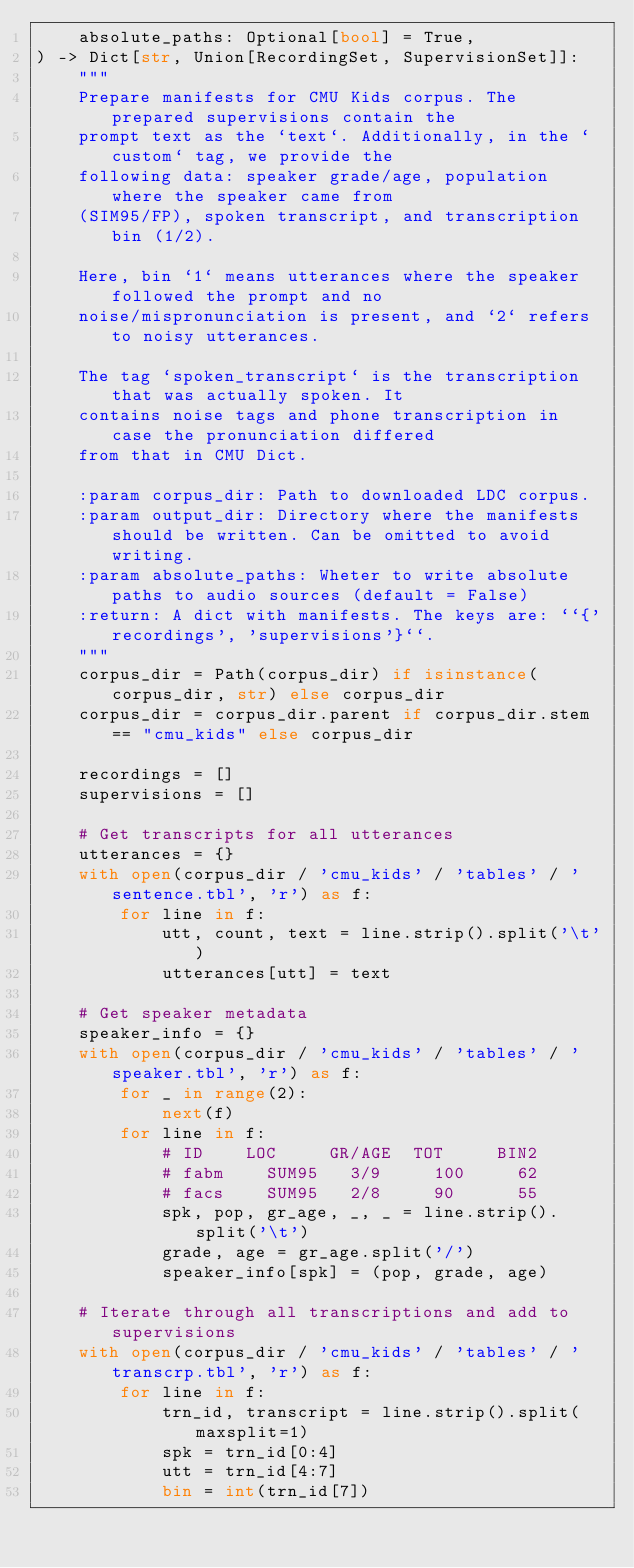<code> <loc_0><loc_0><loc_500><loc_500><_Python_>    absolute_paths: Optional[bool] = True,
) -> Dict[str, Union[RecordingSet, SupervisionSet]]:
    """
    Prepare manifests for CMU Kids corpus. The prepared supervisions contain the
    prompt text as the `text`. Additionally, in the `custom` tag, we provide the
    following data: speaker grade/age, population where the speaker came from
    (SIM95/FP), spoken transcript, and transcription bin (1/2).

    Here, bin `1` means utterances where the speaker followed the prompt and no
    noise/mispronunciation is present, and `2` refers to noisy utterances.

    The tag `spoken_transcript` is the transcription that was actually spoken. It
    contains noise tags and phone transcription in case the pronunciation differed
    from that in CMU Dict.

    :param corpus_dir: Path to downloaded LDC corpus.
    :param output_dir: Directory where the manifests should be written. Can be omitted to avoid writing.
    :param absolute_paths: Wheter to write absolute paths to audio sources (default = False)
    :return: A dict with manifests. The keys are: ``{'recordings', 'supervisions'}``.
    """
    corpus_dir = Path(corpus_dir) if isinstance(corpus_dir, str) else corpus_dir
    corpus_dir = corpus_dir.parent if corpus_dir.stem == "cmu_kids" else corpus_dir

    recordings = []
    supervisions = []

    # Get transcripts for all utterances
    utterances = {}
    with open(corpus_dir / 'cmu_kids' / 'tables' / 'sentence.tbl', 'r') as f:
        for line in f:
            utt, count, text = line.strip().split('\t')
            utterances[utt] = text

    # Get speaker metadata
    speaker_info = {}
    with open(corpus_dir / 'cmu_kids' / 'tables' / 'speaker.tbl', 'r') as f:
        for _ in range(2):
            next(f)
        for line in f:
            # ID    LOC     GR/AGE  TOT     BIN2
            # fabm    SUM95   3/9     100     62
            # facs    SUM95   2/8     90      55
            spk, pop, gr_age, _, _ = line.strip().split('\t')
            grade, age = gr_age.split('/')
            speaker_info[spk] = (pop, grade, age)

    # Iterate through all transcriptions and add to supervisions
    with open(corpus_dir / 'cmu_kids' / 'tables' / 'transcrp.tbl', 'r') as f:
        for line in f:
            trn_id, transcript = line.strip().split(maxsplit=1)
            spk = trn_id[0:4]
            utt = trn_id[4:7]
            bin = int(trn_id[7])</code> 